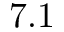<formula> <loc_0><loc_0><loc_500><loc_500>7 . 1</formula> 